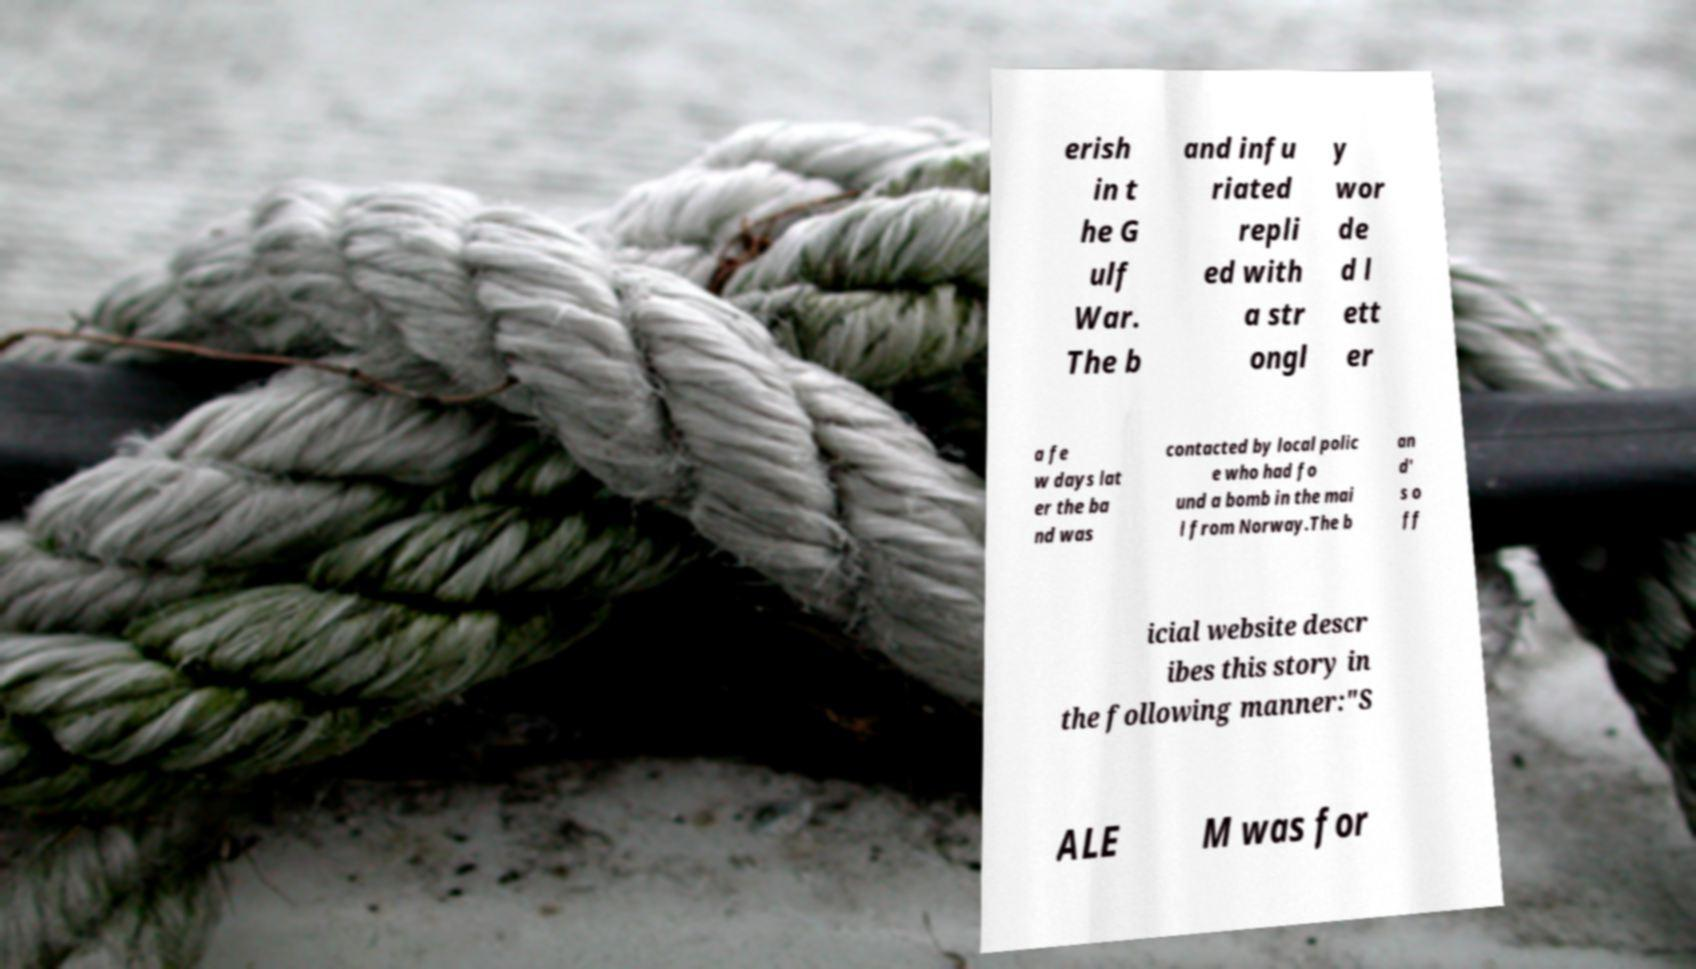Could you assist in decoding the text presented in this image and type it out clearly? erish in t he G ulf War. The b and infu riated repli ed with a str ongl y wor de d l ett er a fe w days lat er the ba nd was contacted by local polic e who had fo und a bomb in the mai l from Norway.The b an d' s o ff icial website descr ibes this story in the following manner:"S ALE M was for 